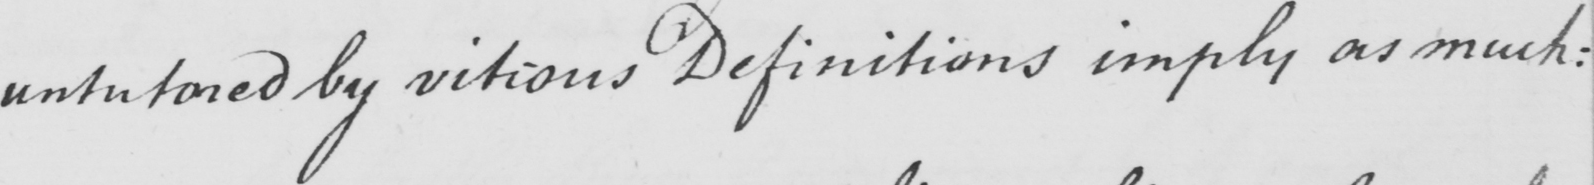What does this handwritten line say? untutored by vitious Definitions imply as much : 